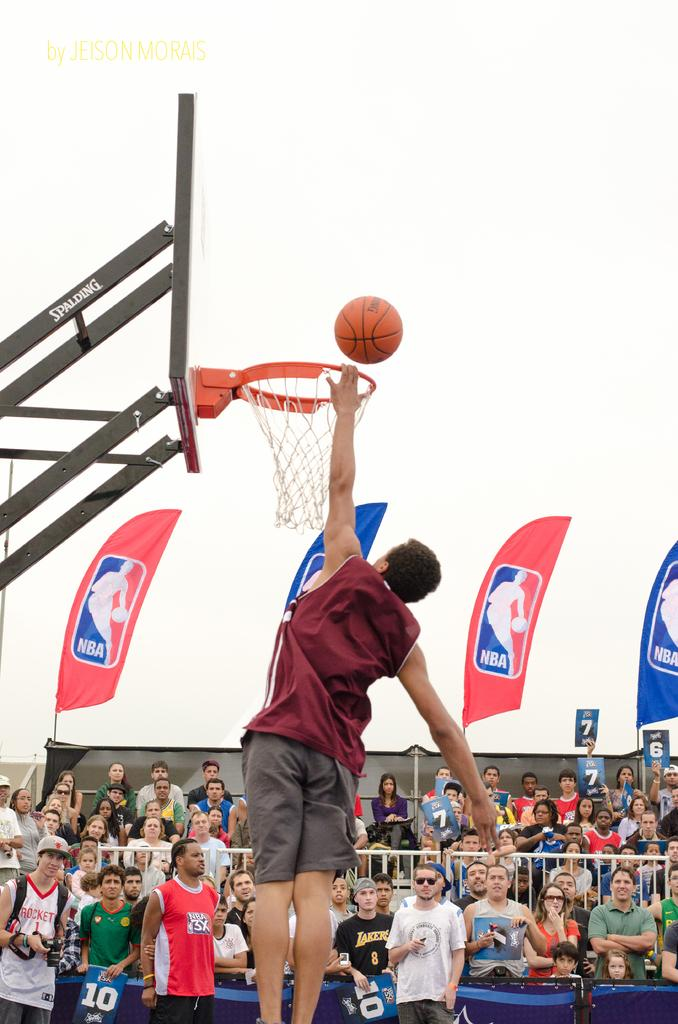What activity is the person in the image engaged in? There is a person playing basketball in the image. What can be seen in the background of the image? There are audience members in the background of the image. What else is present in the image besides the person playing basketball? There are banners visible in the image. How would you describe the weather based on the image? The sky is clear in the image, suggesting good weather. What type of glove is the person wearing while solving arithmetic problems in the image? There is no glove or arithmetic problem present in the image; it features a person playing basketball with audience members, banners, and a clear sky in the background. 